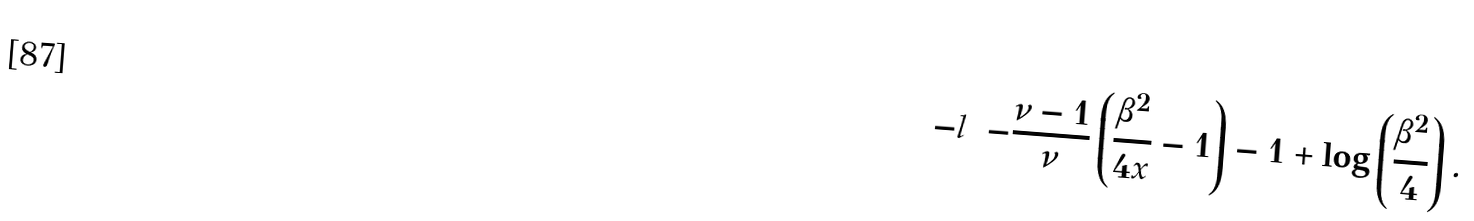Convert formula to latex. <formula><loc_0><loc_0><loc_500><loc_500>- l = - \frac { \nu - 1 } { \nu } \left ( \frac { \beta ^ { 2 } } { 4 x } - 1 \right ) - 1 + \log \left ( \frac { \beta ^ { 2 } } { 4 } \right ) .</formula> 